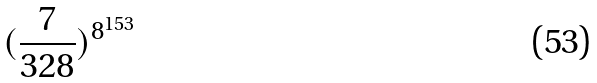<formula> <loc_0><loc_0><loc_500><loc_500>( \frac { 7 } { 3 2 8 } ) ^ { 8 ^ { 1 5 3 } }</formula> 